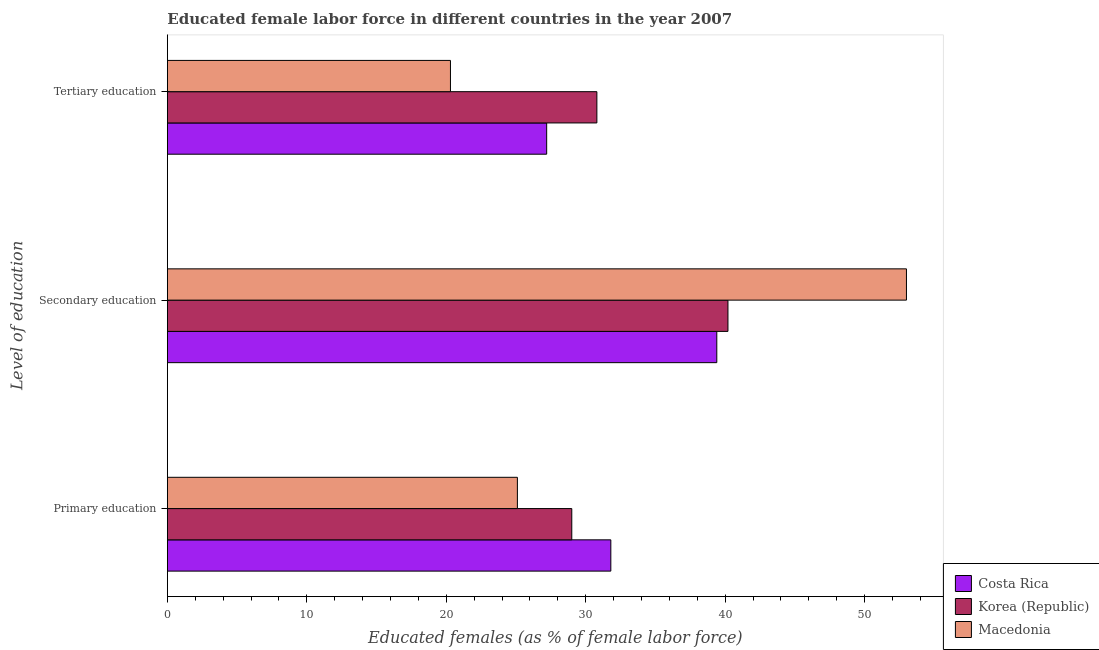Are the number of bars per tick equal to the number of legend labels?
Your answer should be very brief. Yes. Are the number of bars on each tick of the Y-axis equal?
Offer a very short reply. Yes. What is the label of the 2nd group of bars from the top?
Your response must be concise. Secondary education. What is the percentage of female labor force who received tertiary education in Costa Rica?
Make the answer very short. 27.2. Across all countries, what is the maximum percentage of female labor force who received tertiary education?
Keep it short and to the point. 30.8. Across all countries, what is the minimum percentage of female labor force who received secondary education?
Provide a short and direct response. 39.4. In which country was the percentage of female labor force who received secondary education maximum?
Your answer should be very brief. Macedonia. In which country was the percentage of female labor force who received tertiary education minimum?
Keep it short and to the point. Macedonia. What is the total percentage of female labor force who received primary education in the graph?
Provide a short and direct response. 85.9. What is the difference between the percentage of female labor force who received primary education in Costa Rica and that in Korea (Republic)?
Give a very brief answer. 2.8. What is the difference between the percentage of female labor force who received primary education in Korea (Republic) and the percentage of female labor force who received secondary education in Macedonia?
Make the answer very short. -24. What is the average percentage of female labor force who received tertiary education per country?
Your answer should be compact. 26.1. What is the difference between the percentage of female labor force who received tertiary education and percentage of female labor force who received secondary education in Macedonia?
Your response must be concise. -32.7. In how many countries, is the percentage of female labor force who received primary education greater than 16 %?
Ensure brevity in your answer.  3. What is the ratio of the percentage of female labor force who received primary education in Korea (Republic) to that in Costa Rica?
Provide a succinct answer. 0.91. What is the difference between the highest and the second highest percentage of female labor force who received secondary education?
Keep it short and to the point. 12.8. What is the difference between the highest and the lowest percentage of female labor force who received primary education?
Ensure brevity in your answer.  6.7. What does the 2nd bar from the top in Primary education represents?
Keep it short and to the point. Korea (Republic). Is it the case that in every country, the sum of the percentage of female labor force who received primary education and percentage of female labor force who received secondary education is greater than the percentage of female labor force who received tertiary education?
Keep it short and to the point. Yes. How many bars are there?
Keep it short and to the point. 9. Are the values on the major ticks of X-axis written in scientific E-notation?
Offer a very short reply. No. Does the graph contain any zero values?
Provide a short and direct response. No. Does the graph contain grids?
Keep it short and to the point. No. Where does the legend appear in the graph?
Keep it short and to the point. Bottom right. How many legend labels are there?
Provide a succinct answer. 3. How are the legend labels stacked?
Your response must be concise. Vertical. What is the title of the graph?
Make the answer very short. Educated female labor force in different countries in the year 2007. Does "Senegal" appear as one of the legend labels in the graph?
Provide a short and direct response. No. What is the label or title of the X-axis?
Make the answer very short. Educated females (as % of female labor force). What is the label or title of the Y-axis?
Your answer should be compact. Level of education. What is the Educated females (as % of female labor force) in Costa Rica in Primary education?
Your answer should be compact. 31.8. What is the Educated females (as % of female labor force) in Korea (Republic) in Primary education?
Give a very brief answer. 29. What is the Educated females (as % of female labor force) of Macedonia in Primary education?
Provide a short and direct response. 25.1. What is the Educated females (as % of female labor force) of Costa Rica in Secondary education?
Your answer should be very brief. 39.4. What is the Educated females (as % of female labor force) in Korea (Republic) in Secondary education?
Ensure brevity in your answer.  40.2. What is the Educated females (as % of female labor force) in Costa Rica in Tertiary education?
Offer a very short reply. 27.2. What is the Educated females (as % of female labor force) of Korea (Republic) in Tertiary education?
Provide a short and direct response. 30.8. What is the Educated females (as % of female labor force) of Macedonia in Tertiary education?
Provide a short and direct response. 20.3. Across all Level of education, what is the maximum Educated females (as % of female labor force) in Costa Rica?
Offer a very short reply. 39.4. Across all Level of education, what is the maximum Educated females (as % of female labor force) in Korea (Republic)?
Your answer should be very brief. 40.2. Across all Level of education, what is the minimum Educated females (as % of female labor force) of Costa Rica?
Your answer should be very brief. 27.2. Across all Level of education, what is the minimum Educated females (as % of female labor force) of Korea (Republic)?
Offer a very short reply. 29. Across all Level of education, what is the minimum Educated females (as % of female labor force) of Macedonia?
Offer a terse response. 20.3. What is the total Educated females (as % of female labor force) of Costa Rica in the graph?
Make the answer very short. 98.4. What is the total Educated females (as % of female labor force) in Korea (Republic) in the graph?
Offer a very short reply. 100. What is the total Educated females (as % of female labor force) of Macedonia in the graph?
Keep it short and to the point. 98.4. What is the difference between the Educated females (as % of female labor force) of Costa Rica in Primary education and that in Secondary education?
Offer a very short reply. -7.6. What is the difference between the Educated females (as % of female labor force) of Macedonia in Primary education and that in Secondary education?
Your answer should be compact. -27.9. What is the difference between the Educated females (as % of female labor force) of Costa Rica in Primary education and that in Tertiary education?
Provide a short and direct response. 4.6. What is the difference between the Educated females (as % of female labor force) in Korea (Republic) in Primary education and that in Tertiary education?
Offer a terse response. -1.8. What is the difference between the Educated females (as % of female labor force) in Costa Rica in Secondary education and that in Tertiary education?
Your answer should be very brief. 12.2. What is the difference between the Educated females (as % of female labor force) of Macedonia in Secondary education and that in Tertiary education?
Your answer should be very brief. 32.7. What is the difference between the Educated females (as % of female labor force) in Costa Rica in Primary education and the Educated females (as % of female labor force) in Korea (Republic) in Secondary education?
Give a very brief answer. -8.4. What is the difference between the Educated females (as % of female labor force) of Costa Rica in Primary education and the Educated females (as % of female labor force) of Macedonia in Secondary education?
Offer a terse response. -21.2. What is the difference between the Educated females (as % of female labor force) in Costa Rica in Primary education and the Educated females (as % of female labor force) in Korea (Republic) in Tertiary education?
Offer a very short reply. 1. What is the difference between the Educated females (as % of female labor force) of Costa Rica in Secondary education and the Educated females (as % of female labor force) of Korea (Republic) in Tertiary education?
Your answer should be very brief. 8.6. What is the difference between the Educated females (as % of female labor force) in Korea (Republic) in Secondary education and the Educated females (as % of female labor force) in Macedonia in Tertiary education?
Offer a very short reply. 19.9. What is the average Educated females (as % of female labor force) in Costa Rica per Level of education?
Offer a terse response. 32.8. What is the average Educated females (as % of female labor force) in Korea (Republic) per Level of education?
Ensure brevity in your answer.  33.33. What is the average Educated females (as % of female labor force) in Macedonia per Level of education?
Your answer should be very brief. 32.8. What is the difference between the Educated females (as % of female labor force) of Costa Rica and Educated females (as % of female labor force) of Korea (Republic) in Primary education?
Offer a terse response. 2.8. What is the difference between the Educated females (as % of female labor force) in Costa Rica and Educated females (as % of female labor force) in Macedonia in Primary education?
Ensure brevity in your answer.  6.7. What is the difference between the Educated females (as % of female labor force) in Korea (Republic) and Educated females (as % of female labor force) in Macedonia in Primary education?
Give a very brief answer. 3.9. What is the difference between the Educated females (as % of female labor force) of Costa Rica and Educated females (as % of female labor force) of Macedonia in Secondary education?
Make the answer very short. -13.6. What is the difference between the Educated females (as % of female labor force) of Korea (Republic) and Educated females (as % of female labor force) of Macedonia in Secondary education?
Offer a very short reply. -12.8. What is the ratio of the Educated females (as % of female labor force) of Costa Rica in Primary education to that in Secondary education?
Ensure brevity in your answer.  0.81. What is the ratio of the Educated females (as % of female labor force) of Korea (Republic) in Primary education to that in Secondary education?
Keep it short and to the point. 0.72. What is the ratio of the Educated females (as % of female labor force) in Macedonia in Primary education to that in Secondary education?
Your answer should be very brief. 0.47. What is the ratio of the Educated females (as % of female labor force) in Costa Rica in Primary education to that in Tertiary education?
Your answer should be compact. 1.17. What is the ratio of the Educated females (as % of female labor force) of Korea (Republic) in Primary education to that in Tertiary education?
Provide a succinct answer. 0.94. What is the ratio of the Educated females (as % of female labor force) of Macedonia in Primary education to that in Tertiary education?
Your answer should be compact. 1.24. What is the ratio of the Educated females (as % of female labor force) in Costa Rica in Secondary education to that in Tertiary education?
Provide a succinct answer. 1.45. What is the ratio of the Educated females (as % of female labor force) of Korea (Republic) in Secondary education to that in Tertiary education?
Provide a succinct answer. 1.31. What is the ratio of the Educated females (as % of female labor force) of Macedonia in Secondary education to that in Tertiary education?
Offer a terse response. 2.61. What is the difference between the highest and the second highest Educated females (as % of female labor force) of Costa Rica?
Make the answer very short. 7.6. What is the difference between the highest and the second highest Educated females (as % of female labor force) in Macedonia?
Ensure brevity in your answer.  27.9. What is the difference between the highest and the lowest Educated females (as % of female labor force) in Costa Rica?
Provide a short and direct response. 12.2. What is the difference between the highest and the lowest Educated females (as % of female labor force) of Macedonia?
Ensure brevity in your answer.  32.7. 